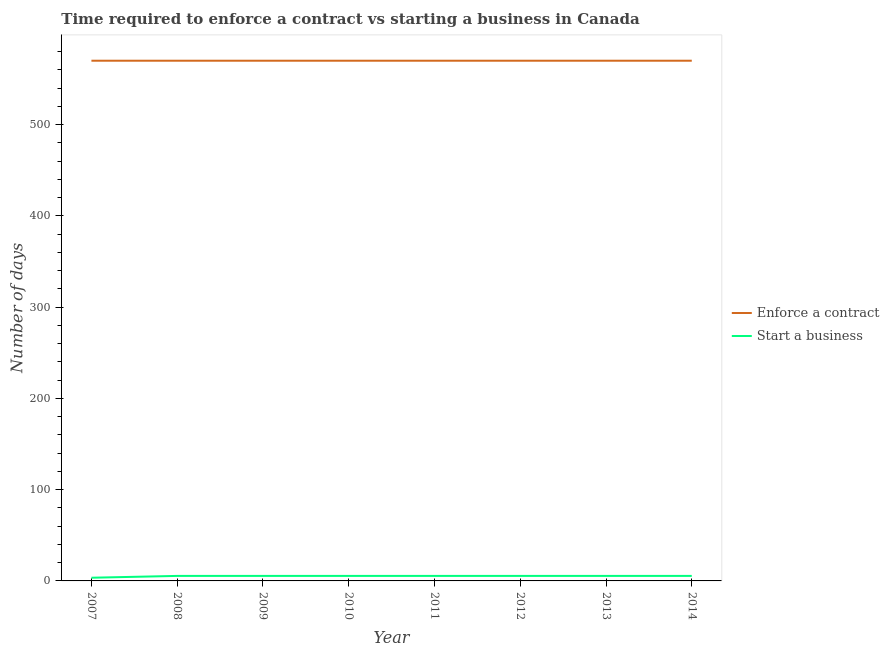What is the number of days to start a business in 2009?
Make the answer very short. 5.5. Across all years, what is the maximum number of days to start a business?
Your response must be concise. 5.5. Across all years, what is the minimum number of days to enforece a contract?
Ensure brevity in your answer.  570. In which year was the number of days to enforece a contract maximum?
Provide a short and direct response. 2007. What is the total number of days to enforece a contract in the graph?
Offer a very short reply. 4560. What is the difference between the number of days to enforece a contract in 2007 and that in 2010?
Ensure brevity in your answer.  0. What is the difference between the number of days to enforece a contract in 2009 and the number of days to start a business in 2010?
Your answer should be compact. 564.5. What is the average number of days to enforece a contract per year?
Offer a terse response. 570. In the year 2007, what is the difference between the number of days to start a business and number of days to enforece a contract?
Your response must be concise. -566.5. In how many years, is the number of days to start a business greater than 480 days?
Provide a succinct answer. 0. What is the ratio of the number of days to enforece a contract in 2007 to that in 2011?
Your response must be concise. 1. Is the difference between the number of days to start a business in 2007 and 2009 greater than the difference between the number of days to enforece a contract in 2007 and 2009?
Make the answer very short. No. What is the difference between the highest and the lowest number of days to enforece a contract?
Your answer should be compact. 0. In how many years, is the number of days to enforece a contract greater than the average number of days to enforece a contract taken over all years?
Give a very brief answer. 0. Does the number of days to start a business monotonically increase over the years?
Provide a short and direct response. No. Is the number of days to start a business strictly less than the number of days to enforece a contract over the years?
Give a very brief answer. Yes. How many years are there in the graph?
Offer a terse response. 8. What is the difference between two consecutive major ticks on the Y-axis?
Ensure brevity in your answer.  100. Does the graph contain any zero values?
Ensure brevity in your answer.  No. How are the legend labels stacked?
Offer a very short reply. Vertical. What is the title of the graph?
Your answer should be compact. Time required to enforce a contract vs starting a business in Canada. What is the label or title of the X-axis?
Offer a very short reply. Year. What is the label or title of the Y-axis?
Provide a succinct answer. Number of days. What is the Number of days in Enforce a contract in 2007?
Provide a succinct answer. 570. What is the Number of days in Enforce a contract in 2008?
Offer a terse response. 570. What is the Number of days of Enforce a contract in 2009?
Ensure brevity in your answer.  570. What is the Number of days in Enforce a contract in 2010?
Ensure brevity in your answer.  570. What is the Number of days in Enforce a contract in 2011?
Offer a terse response. 570. What is the Number of days of Enforce a contract in 2012?
Make the answer very short. 570. What is the Number of days of Enforce a contract in 2013?
Offer a terse response. 570. What is the Number of days in Enforce a contract in 2014?
Keep it short and to the point. 570. What is the Number of days of Start a business in 2014?
Give a very brief answer. 5.5. Across all years, what is the maximum Number of days of Enforce a contract?
Make the answer very short. 570. Across all years, what is the maximum Number of days in Start a business?
Your answer should be compact. 5.5. Across all years, what is the minimum Number of days in Enforce a contract?
Your response must be concise. 570. Across all years, what is the minimum Number of days of Start a business?
Your answer should be very brief. 3.5. What is the total Number of days in Enforce a contract in the graph?
Your answer should be very brief. 4560. What is the difference between the Number of days in Enforce a contract in 2007 and that in 2008?
Ensure brevity in your answer.  0. What is the difference between the Number of days of Start a business in 2007 and that in 2008?
Provide a short and direct response. -2. What is the difference between the Number of days of Enforce a contract in 2007 and that in 2009?
Make the answer very short. 0. What is the difference between the Number of days in Start a business in 2007 and that in 2009?
Ensure brevity in your answer.  -2. What is the difference between the Number of days in Enforce a contract in 2007 and that in 2010?
Your response must be concise. 0. What is the difference between the Number of days in Start a business in 2007 and that in 2011?
Provide a short and direct response. -2. What is the difference between the Number of days of Enforce a contract in 2007 and that in 2012?
Your answer should be very brief. 0. What is the difference between the Number of days of Start a business in 2007 and that in 2013?
Provide a short and direct response. -2. What is the difference between the Number of days of Enforce a contract in 2007 and that in 2014?
Your response must be concise. 0. What is the difference between the Number of days in Enforce a contract in 2008 and that in 2009?
Your answer should be very brief. 0. What is the difference between the Number of days in Start a business in 2008 and that in 2009?
Your response must be concise. 0. What is the difference between the Number of days in Start a business in 2008 and that in 2010?
Ensure brevity in your answer.  0. What is the difference between the Number of days of Start a business in 2008 and that in 2011?
Provide a succinct answer. 0. What is the difference between the Number of days in Start a business in 2008 and that in 2012?
Keep it short and to the point. 0. What is the difference between the Number of days of Enforce a contract in 2008 and that in 2013?
Your answer should be very brief. 0. What is the difference between the Number of days in Start a business in 2008 and that in 2013?
Give a very brief answer. 0. What is the difference between the Number of days of Start a business in 2008 and that in 2014?
Provide a short and direct response. 0. What is the difference between the Number of days in Start a business in 2009 and that in 2010?
Provide a succinct answer. 0. What is the difference between the Number of days of Start a business in 2009 and that in 2011?
Offer a very short reply. 0. What is the difference between the Number of days of Enforce a contract in 2009 and that in 2012?
Offer a very short reply. 0. What is the difference between the Number of days of Start a business in 2009 and that in 2014?
Provide a short and direct response. 0. What is the difference between the Number of days in Start a business in 2010 and that in 2011?
Your response must be concise. 0. What is the difference between the Number of days in Enforce a contract in 2010 and that in 2012?
Make the answer very short. 0. What is the difference between the Number of days in Start a business in 2010 and that in 2012?
Your answer should be very brief. 0. What is the difference between the Number of days of Enforce a contract in 2010 and that in 2014?
Your response must be concise. 0. What is the difference between the Number of days in Start a business in 2010 and that in 2014?
Make the answer very short. 0. What is the difference between the Number of days of Start a business in 2011 and that in 2012?
Your answer should be compact. 0. What is the difference between the Number of days in Enforce a contract in 2011 and that in 2013?
Your response must be concise. 0. What is the difference between the Number of days of Enforce a contract in 2012 and that in 2013?
Keep it short and to the point. 0. What is the difference between the Number of days of Start a business in 2012 and that in 2013?
Give a very brief answer. 0. What is the difference between the Number of days of Enforce a contract in 2013 and that in 2014?
Provide a succinct answer. 0. What is the difference between the Number of days in Start a business in 2013 and that in 2014?
Provide a succinct answer. 0. What is the difference between the Number of days of Enforce a contract in 2007 and the Number of days of Start a business in 2008?
Your answer should be compact. 564.5. What is the difference between the Number of days of Enforce a contract in 2007 and the Number of days of Start a business in 2009?
Keep it short and to the point. 564.5. What is the difference between the Number of days of Enforce a contract in 2007 and the Number of days of Start a business in 2010?
Offer a terse response. 564.5. What is the difference between the Number of days in Enforce a contract in 2007 and the Number of days in Start a business in 2011?
Give a very brief answer. 564.5. What is the difference between the Number of days of Enforce a contract in 2007 and the Number of days of Start a business in 2012?
Your response must be concise. 564.5. What is the difference between the Number of days of Enforce a contract in 2007 and the Number of days of Start a business in 2013?
Make the answer very short. 564.5. What is the difference between the Number of days of Enforce a contract in 2007 and the Number of days of Start a business in 2014?
Give a very brief answer. 564.5. What is the difference between the Number of days in Enforce a contract in 2008 and the Number of days in Start a business in 2009?
Offer a terse response. 564.5. What is the difference between the Number of days in Enforce a contract in 2008 and the Number of days in Start a business in 2010?
Provide a succinct answer. 564.5. What is the difference between the Number of days of Enforce a contract in 2008 and the Number of days of Start a business in 2011?
Make the answer very short. 564.5. What is the difference between the Number of days in Enforce a contract in 2008 and the Number of days in Start a business in 2012?
Provide a succinct answer. 564.5. What is the difference between the Number of days in Enforce a contract in 2008 and the Number of days in Start a business in 2013?
Provide a short and direct response. 564.5. What is the difference between the Number of days of Enforce a contract in 2008 and the Number of days of Start a business in 2014?
Your answer should be compact. 564.5. What is the difference between the Number of days of Enforce a contract in 2009 and the Number of days of Start a business in 2010?
Give a very brief answer. 564.5. What is the difference between the Number of days of Enforce a contract in 2009 and the Number of days of Start a business in 2011?
Give a very brief answer. 564.5. What is the difference between the Number of days of Enforce a contract in 2009 and the Number of days of Start a business in 2012?
Your answer should be very brief. 564.5. What is the difference between the Number of days in Enforce a contract in 2009 and the Number of days in Start a business in 2013?
Make the answer very short. 564.5. What is the difference between the Number of days of Enforce a contract in 2009 and the Number of days of Start a business in 2014?
Make the answer very short. 564.5. What is the difference between the Number of days of Enforce a contract in 2010 and the Number of days of Start a business in 2011?
Your answer should be very brief. 564.5. What is the difference between the Number of days of Enforce a contract in 2010 and the Number of days of Start a business in 2012?
Your response must be concise. 564.5. What is the difference between the Number of days of Enforce a contract in 2010 and the Number of days of Start a business in 2013?
Keep it short and to the point. 564.5. What is the difference between the Number of days in Enforce a contract in 2010 and the Number of days in Start a business in 2014?
Provide a succinct answer. 564.5. What is the difference between the Number of days of Enforce a contract in 2011 and the Number of days of Start a business in 2012?
Offer a very short reply. 564.5. What is the difference between the Number of days of Enforce a contract in 2011 and the Number of days of Start a business in 2013?
Make the answer very short. 564.5. What is the difference between the Number of days in Enforce a contract in 2011 and the Number of days in Start a business in 2014?
Give a very brief answer. 564.5. What is the difference between the Number of days in Enforce a contract in 2012 and the Number of days in Start a business in 2013?
Your response must be concise. 564.5. What is the difference between the Number of days of Enforce a contract in 2012 and the Number of days of Start a business in 2014?
Provide a short and direct response. 564.5. What is the difference between the Number of days in Enforce a contract in 2013 and the Number of days in Start a business in 2014?
Your answer should be very brief. 564.5. What is the average Number of days of Enforce a contract per year?
Your answer should be compact. 570. What is the average Number of days in Start a business per year?
Offer a very short reply. 5.25. In the year 2007, what is the difference between the Number of days of Enforce a contract and Number of days of Start a business?
Your answer should be compact. 566.5. In the year 2008, what is the difference between the Number of days of Enforce a contract and Number of days of Start a business?
Keep it short and to the point. 564.5. In the year 2009, what is the difference between the Number of days of Enforce a contract and Number of days of Start a business?
Give a very brief answer. 564.5. In the year 2010, what is the difference between the Number of days of Enforce a contract and Number of days of Start a business?
Your answer should be compact. 564.5. In the year 2011, what is the difference between the Number of days of Enforce a contract and Number of days of Start a business?
Your answer should be very brief. 564.5. In the year 2012, what is the difference between the Number of days of Enforce a contract and Number of days of Start a business?
Make the answer very short. 564.5. In the year 2013, what is the difference between the Number of days in Enforce a contract and Number of days in Start a business?
Ensure brevity in your answer.  564.5. In the year 2014, what is the difference between the Number of days in Enforce a contract and Number of days in Start a business?
Make the answer very short. 564.5. What is the ratio of the Number of days in Start a business in 2007 to that in 2008?
Make the answer very short. 0.64. What is the ratio of the Number of days in Enforce a contract in 2007 to that in 2009?
Offer a very short reply. 1. What is the ratio of the Number of days of Start a business in 2007 to that in 2009?
Keep it short and to the point. 0.64. What is the ratio of the Number of days of Enforce a contract in 2007 to that in 2010?
Offer a terse response. 1. What is the ratio of the Number of days of Start a business in 2007 to that in 2010?
Provide a succinct answer. 0.64. What is the ratio of the Number of days in Enforce a contract in 2007 to that in 2011?
Give a very brief answer. 1. What is the ratio of the Number of days of Start a business in 2007 to that in 2011?
Make the answer very short. 0.64. What is the ratio of the Number of days of Start a business in 2007 to that in 2012?
Your response must be concise. 0.64. What is the ratio of the Number of days in Start a business in 2007 to that in 2013?
Ensure brevity in your answer.  0.64. What is the ratio of the Number of days of Enforce a contract in 2007 to that in 2014?
Give a very brief answer. 1. What is the ratio of the Number of days in Start a business in 2007 to that in 2014?
Keep it short and to the point. 0.64. What is the ratio of the Number of days of Enforce a contract in 2008 to that in 2009?
Your answer should be compact. 1. What is the ratio of the Number of days in Enforce a contract in 2008 to that in 2010?
Make the answer very short. 1. What is the ratio of the Number of days in Enforce a contract in 2008 to that in 2011?
Give a very brief answer. 1. What is the ratio of the Number of days in Enforce a contract in 2008 to that in 2012?
Keep it short and to the point. 1. What is the ratio of the Number of days of Start a business in 2008 to that in 2012?
Give a very brief answer. 1. What is the ratio of the Number of days in Start a business in 2008 to that in 2014?
Provide a short and direct response. 1. What is the ratio of the Number of days of Enforce a contract in 2009 to that in 2010?
Provide a succinct answer. 1. What is the ratio of the Number of days of Enforce a contract in 2009 to that in 2011?
Your answer should be compact. 1. What is the ratio of the Number of days of Start a business in 2009 to that in 2013?
Ensure brevity in your answer.  1. What is the ratio of the Number of days in Enforce a contract in 2010 to that in 2011?
Provide a succinct answer. 1. What is the ratio of the Number of days in Start a business in 2010 to that in 2011?
Offer a very short reply. 1. What is the ratio of the Number of days of Start a business in 2010 to that in 2012?
Offer a very short reply. 1. What is the ratio of the Number of days of Enforce a contract in 2010 to that in 2014?
Offer a very short reply. 1. What is the ratio of the Number of days of Start a business in 2011 to that in 2012?
Keep it short and to the point. 1. What is the ratio of the Number of days in Enforce a contract in 2011 to that in 2013?
Your answer should be compact. 1. What is the ratio of the Number of days in Start a business in 2011 to that in 2013?
Give a very brief answer. 1. What is the ratio of the Number of days of Start a business in 2011 to that in 2014?
Your answer should be very brief. 1. What is the ratio of the Number of days of Enforce a contract in 2012 to that in 2013?
Your response must be concise. 1. What is the ratio of the Number of days in Start a business in 2012 to that in 2013?
Give a very brief answer. 1. What is the ratio of the Number of days of Enforce a contract in 2012 to that in 2014?
Provide a short and direct response. 1. What is the ratio of the Number of days of Start a business in 2013 to that in 2014?
Keep it short and to the point. 1. What is the difference between the highest and the second highest Number of days in Enforce a contract?
Give a very brief answer. 0. What is the difference between the highest and the second highest Number of days of Start a business?
Offer a terse response. 0. What is the difference between the highest and the lowest Number of days of Enforce a contract?
Offer a very short reply. 0. 